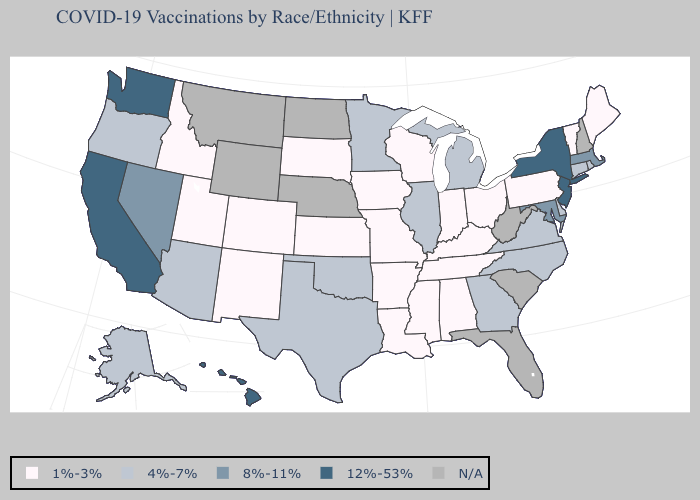Name the states that have a value in the range N/A?
Keep it brief. Florida, Montana, Nebraska, New Hampshire, North Dakota, South Carolina, West Virginia, Wyoming. Name the states that have a value in the range 4%-7%?
Be succinct. Alaska, Arizona, Connecticut, Delaware, Georgia, Illinois, Michigan, Minnesota, North Carolina, Oklahoma, Oregon, Rhode Island, Texas, Virginia. Does Minnesota have the highest value in the MidWest?
Quick response, please. Yes. Does the first symbol in the legend represent the smallest category?
Give a very brief answer. Yes. What is the highest value in the MidWest ?
Quick response, please. 4%-7%. Name the states that have a value in the range N/A?
Write a very short answer. Florida, Montana, Nebraska, New Hampshire, North Dakota, South Carolina, West Virginia, Wyoming. What is the value of North Carolina?
Keep it brief. 4%-7%. Is the legend a continuous bar?
Keep it brief. No. Which states have the lowest value in the USA?
Keep it brief. Alabama, Arkansas, Colorado, Idaho, Indiana, Iowa, Kansas, Kentucky, Louisiana, Maine, Mississippi, Missouri, New Mexico, Ohio, Pennsylvania, South Dakota, Tennessee, Utah, Vermont, Wisconsin. Name the states that have a value in the range 12%-53%?
Answer briefly. California, Hawaii, New Jersey, New York, Washington. Does the map have missing data?
Keep it brief. Yes. Is the legend a continuous bar?
Keep it brief. No. Does Indiana have the highest value in the MidWest?
Concise answer only. No. What is the value of Nebraska?
Short answer required. N/A. 